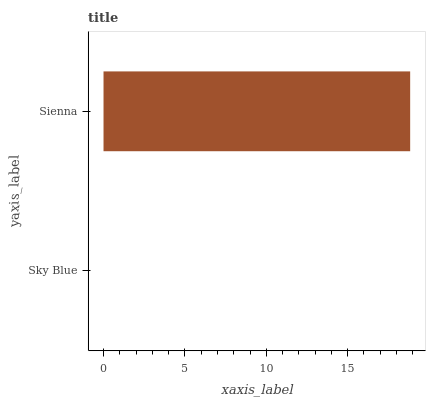Is Sky Blue the minimum?
Answer yes or no. Yes. Is Sienna the maximum?
Answer yes or no. Yes. Is Sienna the minimum?
Answer yes or no. No. Is Sienna greater than Sky Blue?
Answer yes or no. Yes. Is Sky Blue less than Sienna?
Answer yes or no. Yes. Is Sky Blue greater than Sienna?
Answer yes or no. No. Is Sienna less than Sky Blue?
Answer yes or no. No. Is Sienna the high median?
Answer yes or no. Yes. Is Sky Blue the low median?
Answer yes or no. Yes. Is Sky Blue the high median?
Answer yes or no. No. Is Sienna the low median?
Answer yes or no. No. 